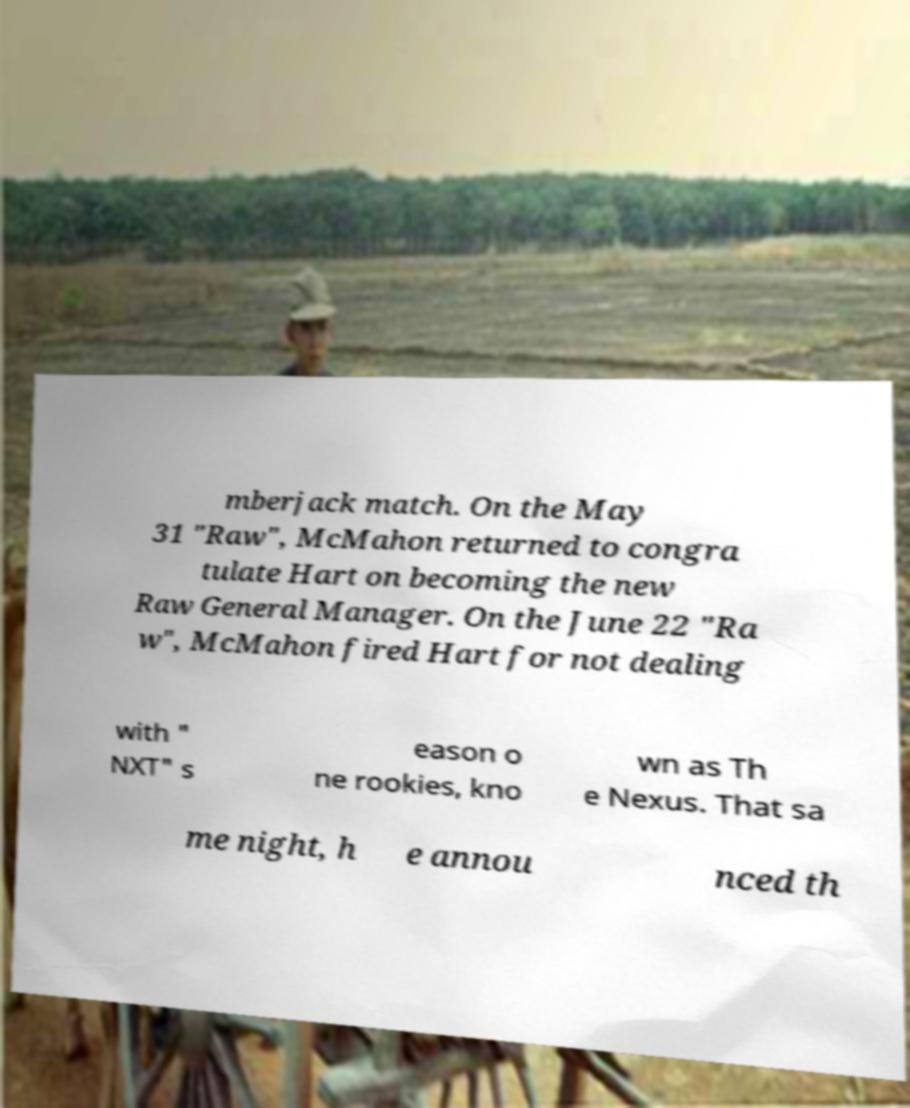For documentation purposes, I need the text within this image transcribed. Could you provide that? mberjack match. On the May 31 "Raw", McMahon returned to congra tulate Hart on becoming the new Raw General Manager. On the June 22 "Ra w", McMahon fired Hart for not dealing with " NXT" s eason o ne rookies, kno wn as Th e Nexus. That sa me night, h e annou nced th 